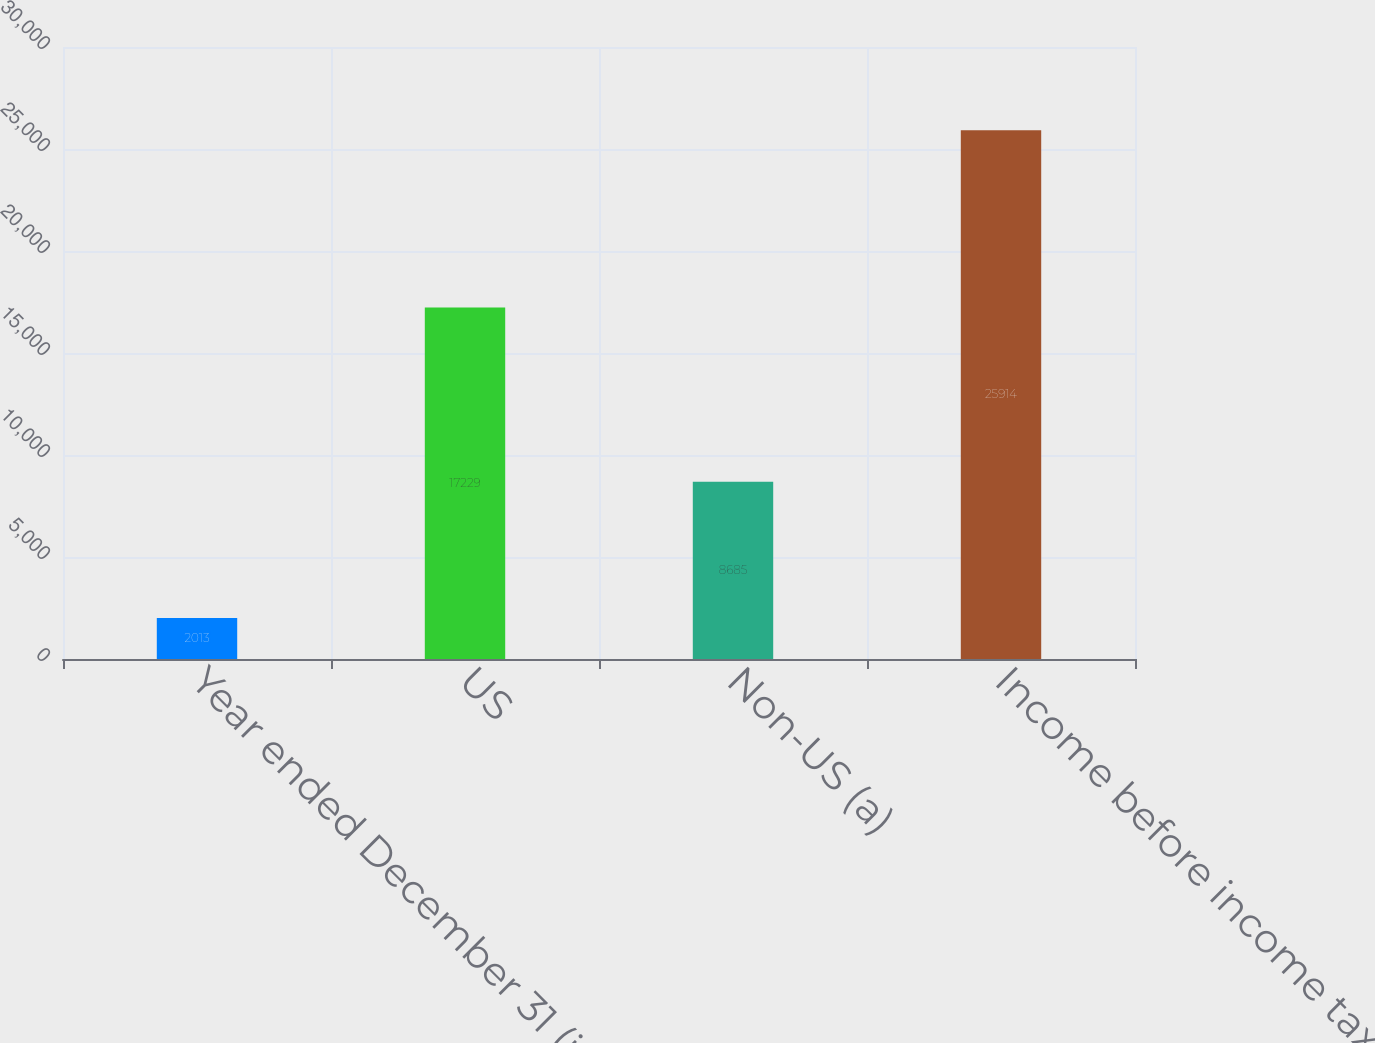<chart> <loc_0><loc_0><loc_500><loc_500><bar_chart><fcel>Year ended December 31 (in<fcel>US<fcel>Non-US (a)<fcel>Income before income tax<nl><fcel>2013<fcel>17229<fcel>8685<fcel>25914<nl></chart> 